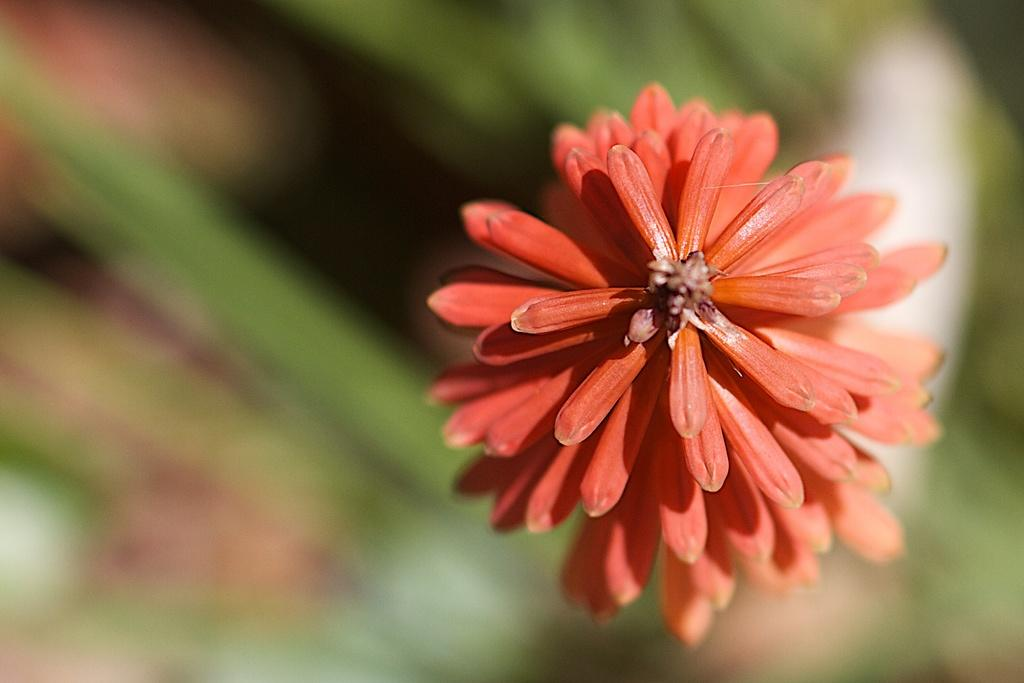What is the appearance of the flower in the image? The flower is beautiful. What color is the flower in the image? The flower is in orange color. How does the flower help in the process of mining in the image? The flower does not help in the process of mining in the image, as there is no reference to mining in the provided facts. What type of tool is used to rake the flower in the image? There is no tool used to rake the flower in the image, as there is no indication of any raking activity. 